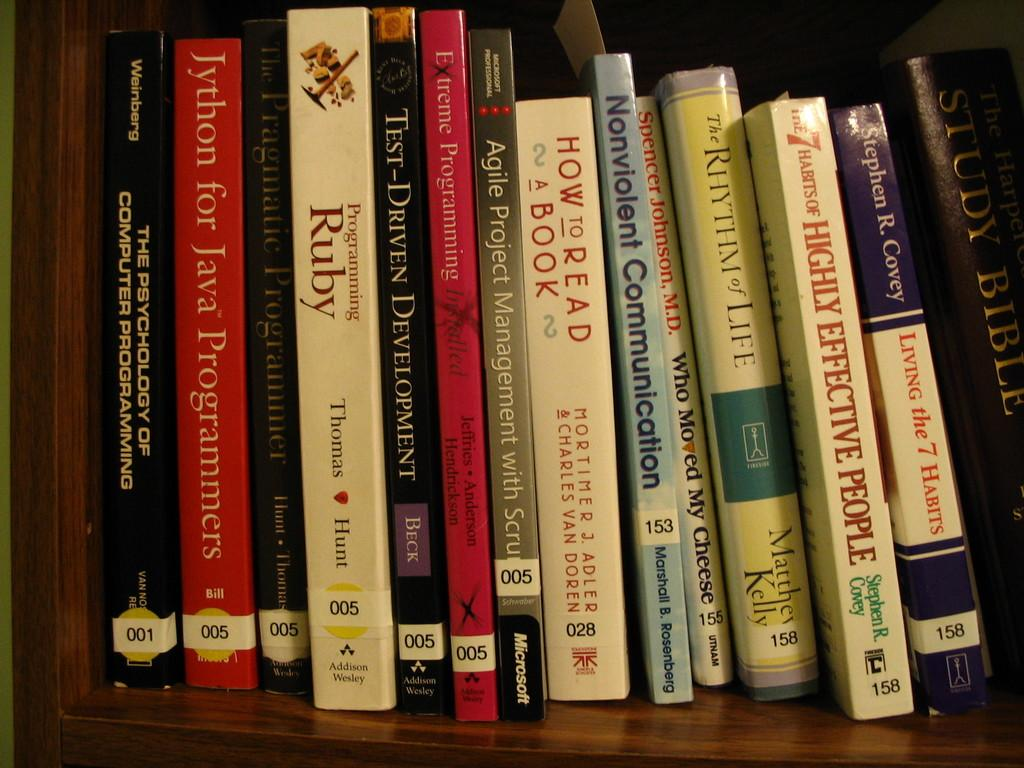<image>
Provide a brief description of the given image. Books standing on a shelf include How to Read a Book. 